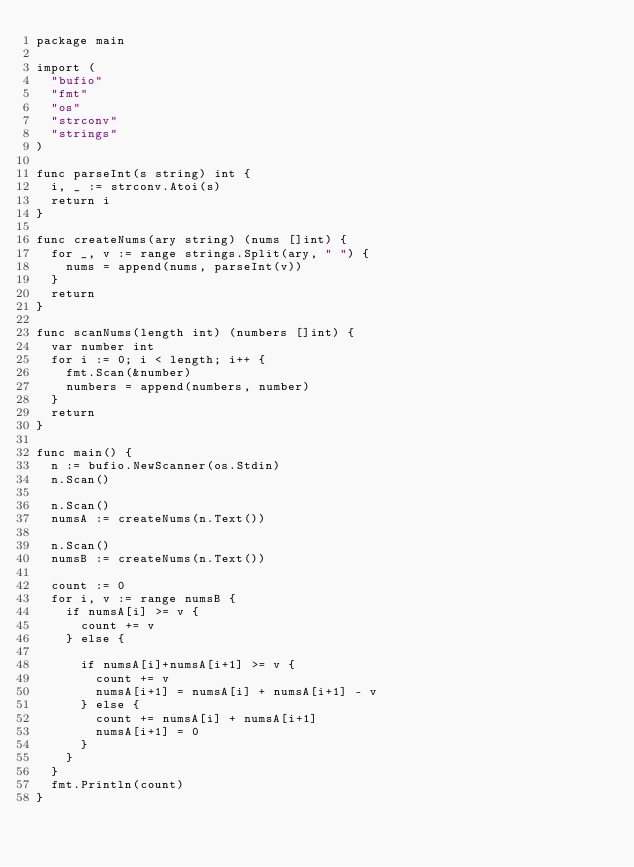<code> <loc_0><loc_0><loc_500><loc_500><_Go_>package main

import (
	"bufio"
	"fmt"
	"os"
	"strconv"
	"strings"
)

func parseInt(s string) int {
	i, _ := strconv.Atoi(s)
	return i
}

func createNums(ary string) (nums []int) {
	for _, v := range strings.Split(ary, " ") {
		nums = append(nums, parseInt(v))
	}
	return
}

func scanNums(length int) (numbers []int) {
	var number int
	for i := 0; i < length; i++ {
		fmt.Scan(&number)
		numbers = append(numbers, number)
	}
	return
}

func main() {
	n := bufio.NewScanner(os.Stdin)
	n.Scan()

	n.Scan()
	numsA := createNums(n.Text())

	n.Scan()
	numsB := createNums(n.Text())

	count := 0
	for i, v := range numsB {
		if numsA[i] >= v {
			count += v
		} else {

			if numsA[i]+numsA[i+1] >= v {
				count += v
				numsA[i+1] = numsA[i] + numsA[i+1] - v
			} else {
				count += numsA[i] + numsA[i+1]
				numsA[i+1] = 0
			}
		}
	}
	fmt.Println(count)
}
</code> 